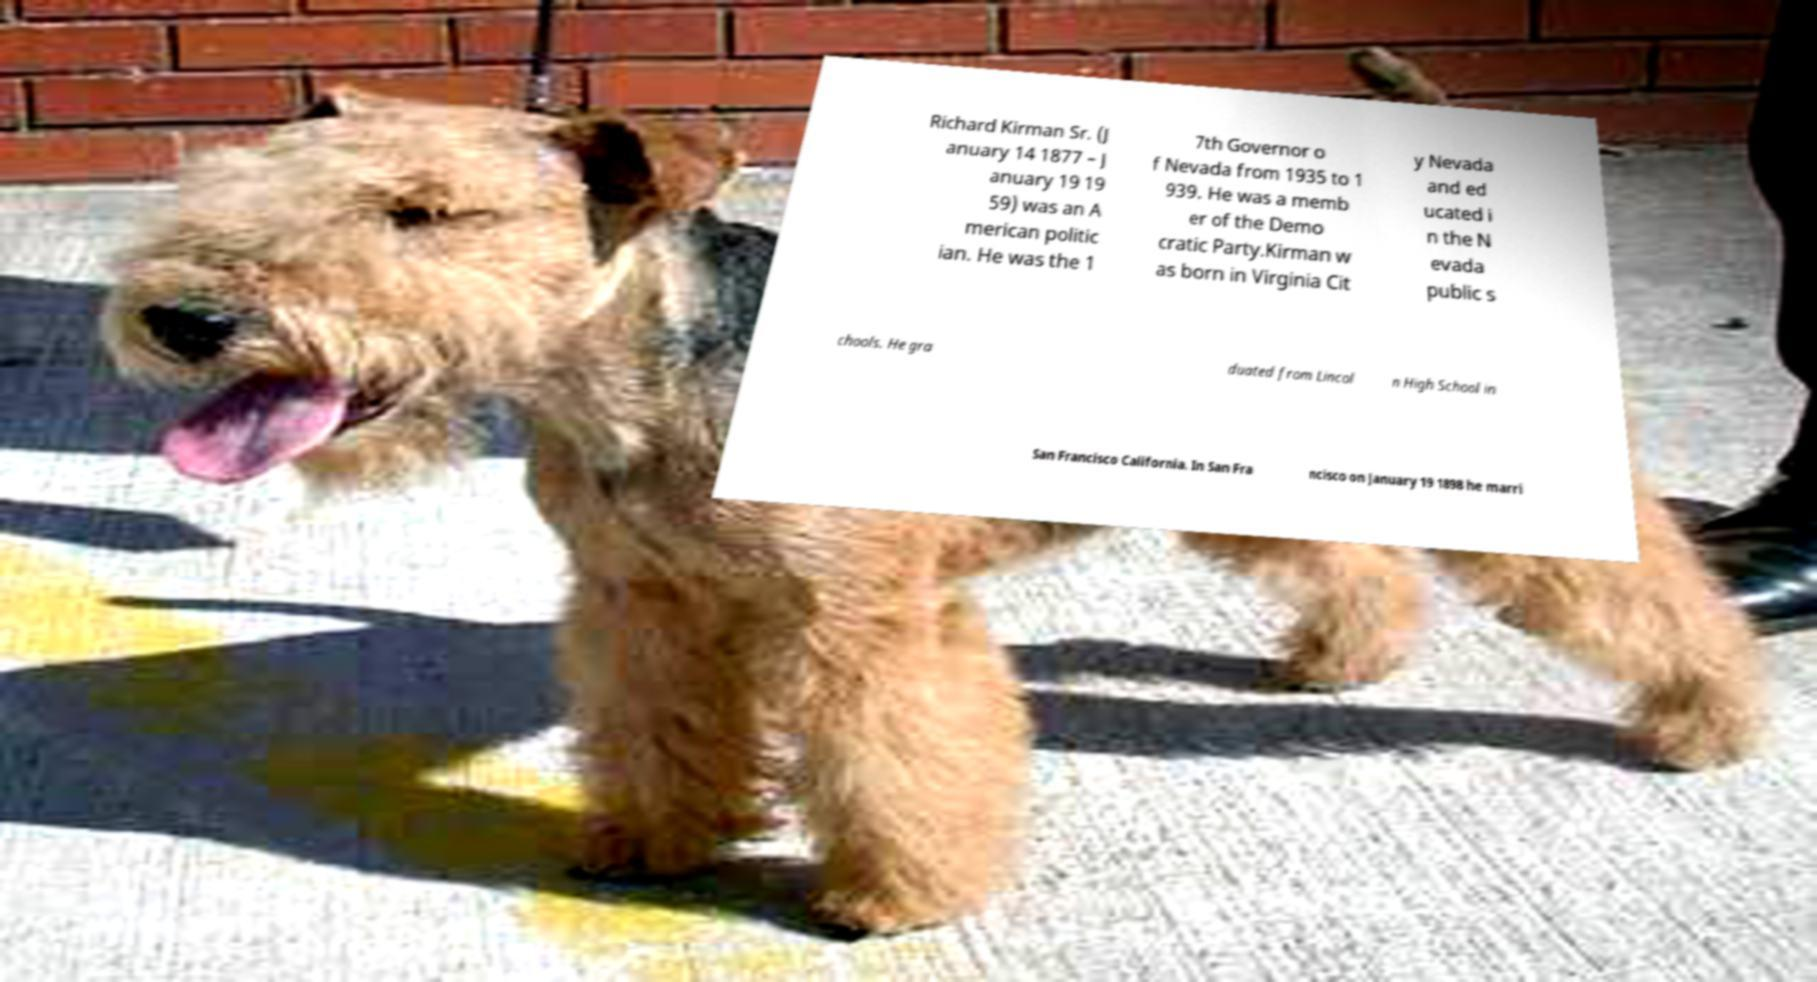What messages or text are displayed in this image? I need them in a readable, typed format. Richard Kirman Sr. (J anuary 14 1877 – J anuary 19 19 59) was an A merican politic ian. He was the 1 7th Governor o f Nevada from 1935 to 1 939. He was a memb er of the Demo cratic Party.Kirman w as born in Virginia Cit y Nevada and ed ucated i n the N evada public s chools. He gra duated from Lincol n High School in San Francisco California. In San Fra ncisco on January 19 1898 he marri 